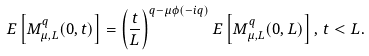<formula> <loc_0><loc_0><loc_500><loc_500>{ E } \left [ M _ { \mu , L } ^ { q } ( 0 , t ) \right ] = \left ( \frac { t } { L } \right ) ^ { q - \mu \phi ( - i q ) } { E } \left [ M _ { \mu , L } ^ { q } ( 0 , L ) \right ] , \, t < L .</formula> 